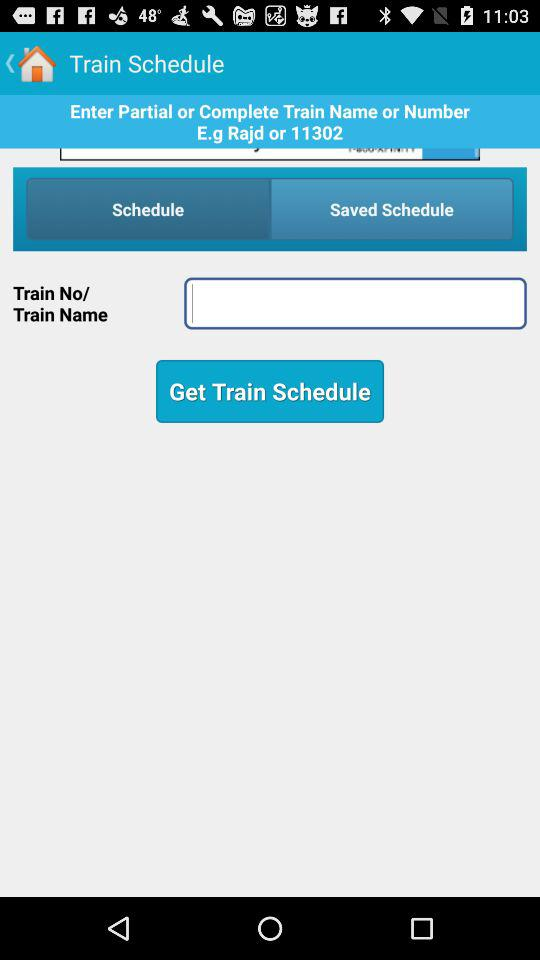What are the requirements to get a train schedule? The requirements to get a train schedule are "Train No/Train Name". 